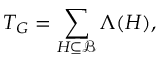Convert formula to latex. <formula><loc_0><loc_0><loc_500><loc_500>T _ { G } = \sum _ { H \subseteq \mathcal { B } } \Lambda ( H ) ,</formula> 